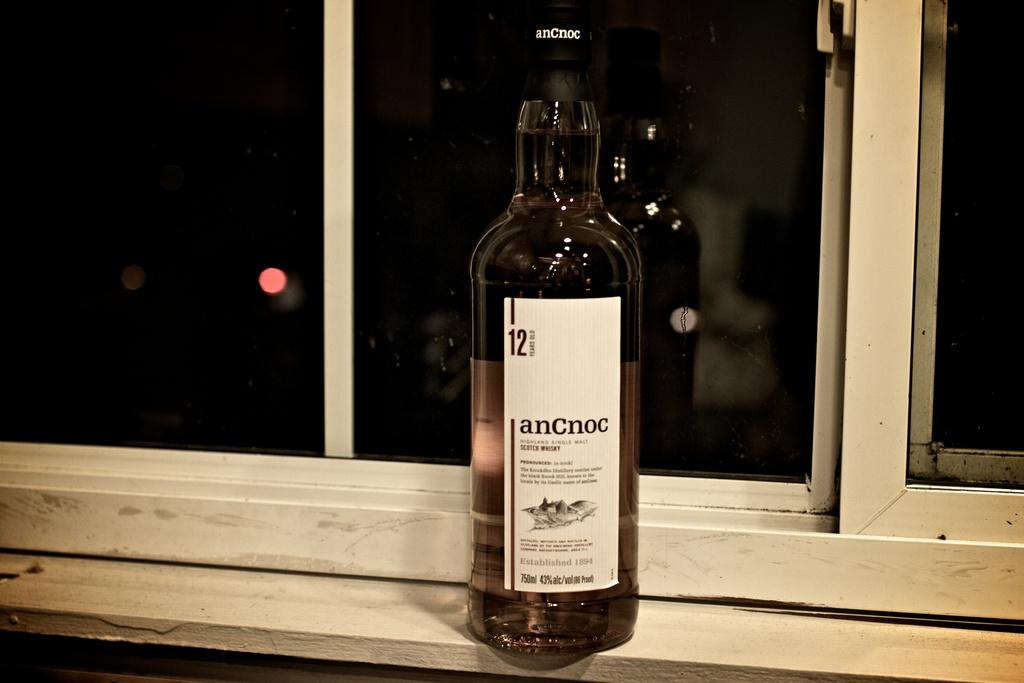Provide a one-sentence caption for the provided image. The AnCnoc alcohol bottle is sitting on the window sill. 